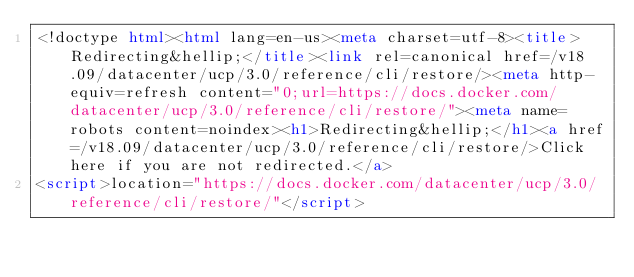Convert code to text. <code><loc_0><loc_0><loc_500><loc_500><_HTML_><!doctype html><html lang=en-us><meta charset=utf-8><title>Redirecting&hellip;</title><link rel=canonical href=/v18.09/datacenter/ucp/3.0/reference/cli/restore/><meta http-equiv=refresh content="0;url=https://docs.docker.com/datacenter/ucp/3.0/reference/cli/restore/"><meta name=robots content=noindex><h1>Redirecting&hellip;</h1><a href=/v18.09/datacenter/ucp/3.0/reference/cli/restore/>Click here if you are not redirected.</a>
<script>location="https://docs.docker.com/datacenter/ucp/3.0/reference/cli/restore/"</script></code> 